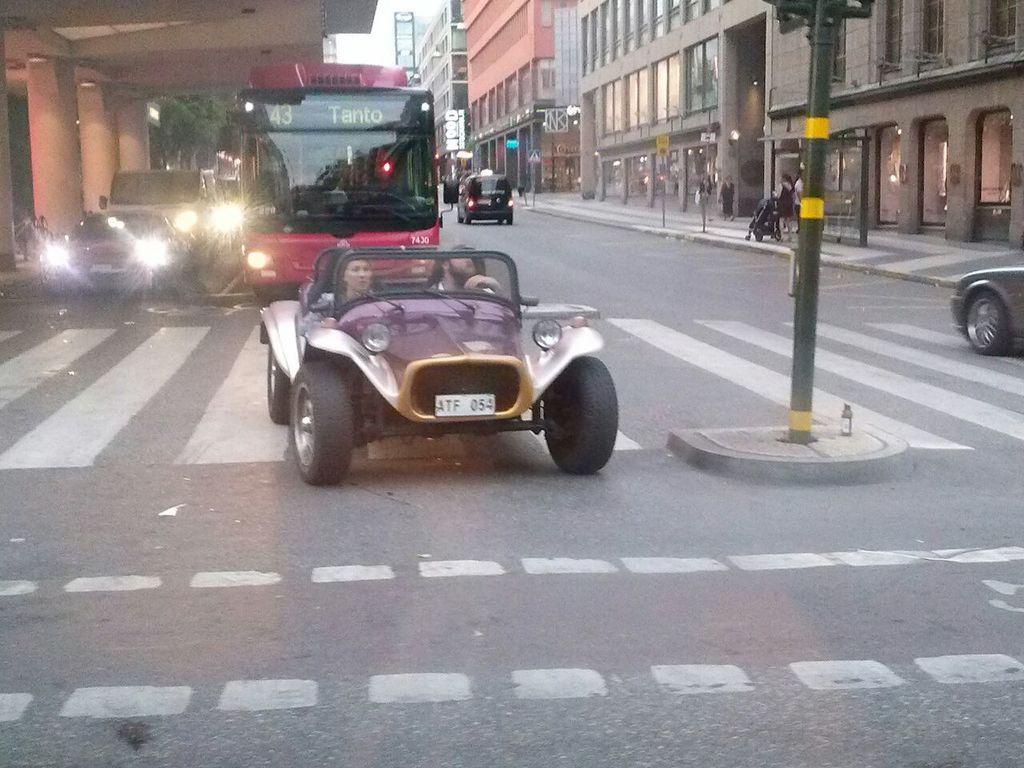In one or two sentences, can you explain what this image depicts? In the image we can see there are many vehicles on the road, this is a road and white lines on the road. There are many buildings, this is a pole, tree and a sky. 